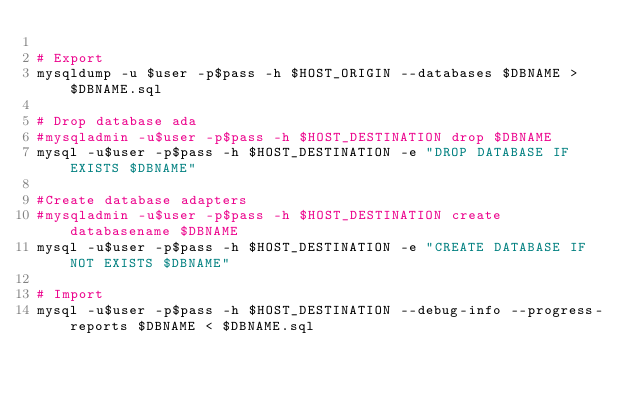Convert code to text. <code><loc_0><loc_0><loc_500><loc_500><_Bash_>
# Export
mysqldump -u $user -p$pass -h $HOST_ORIGIN --databases $DBNAME > $DBNAME.sql

# Drop database ada
#mysqladmin -u$user -p$pass -h $HOST_DESTINATION drop $DBNAME
mysql -u$user -p$pass -h $HOST_DESTINATION -e "DROP DATABASE IF EXISTS $DBNAME"

#Create database adapters
#mysqladmin -u$user -p$pass -h $HOST_DESTINATION create databasename $DBNAME
mysql -u$user -p$pass -h $HOST_DESTINATION -e "CREATE DATABASE IF NOT EXISTS $DBNAME"

# Import
mysql -u$user -p$pass -h $HOST_DESTINATION --debug-info --progress-reports $DBNAME < $DBNAME.sql
</code> 